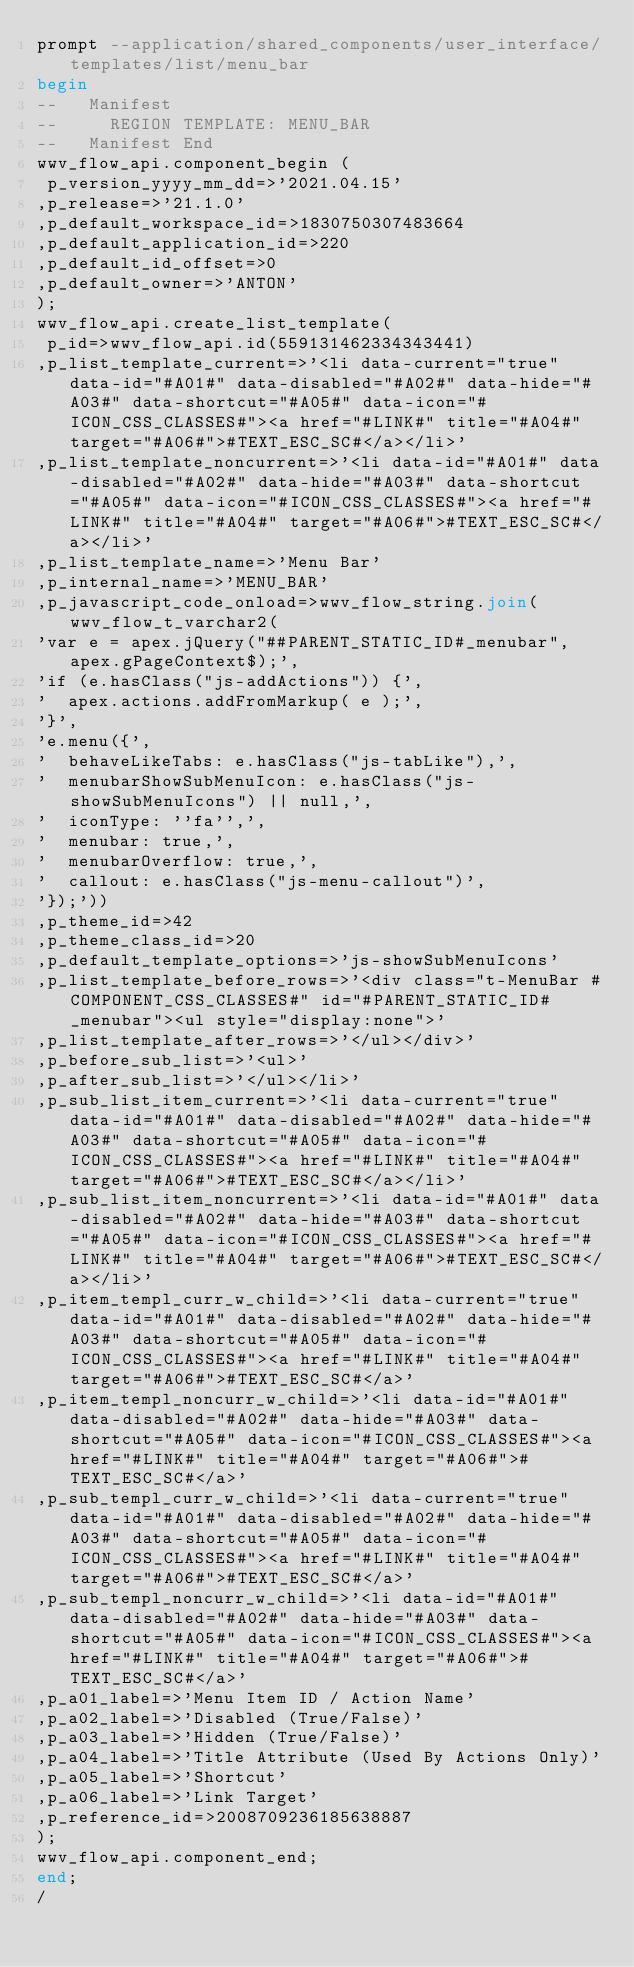<code> <loc_0><loc_0><loc_500><loc_500><_SQL_>prompt --application/shared_components/user_interface/templates/list/menu_bar
begin
--   Manifest
--     REGION TEMPLATE: MENU_BAR
--   Manifest End
wwv_flow_api.component_begin (
 p_version_yyyy_mm_dd=>'2021.04.15'
,p_release=>'21.1.0'
,p_default_workspace_id=>1830750307483664
,p_default_application_id=>220
,p_default_id_offset=>0
,p_default_owner=>'ANTON'
);
wwv_flow_api.create_list_template(
 p_id=>wwv_flow_api.id(559131462334343441)
,p_list_template_current=>'<li data-current="true" data-id="#A01#" data-disabled="#A02#" data-hide="#A03#" data-shortcut="#A05#" data-icon="#ICON_CSS_CLASSES#"><a href="#LINK#" title="#A04#" target="#A06#">#TEXT_ESC_SC#</a></li>'
,p_list_template_noncurrent=>'<li data-id="#A01#" data-disabled="#A02#" data-hide="#A03#" data-shortcut="#A05#" data-icon="#ICON_CSS_CLASSES#"><a href="#LINK#" title="#A04#" target="#A06#">#TEXT_ESC_SC#</a></li>'
,p_list_template_name=>'Menu Bar'
,p_internal_name=>'MENU_BAR'
,p_javascript_code_onload=>wwv_flow_string.join(wwv_flow_t_varchar2(
'var e = apex.jQuery("##PARENT_STATIC_ID#_menubar", apex.gPageContext$);',
'if (e.hasClass("js-addActions")) {',
'  apex.actions.addFromMarkup( e );',
'}',
'e.menu({',
'  behaveLikeTabs: e.hasClass("js-tabLike"),',
'  menubarShowSubMenuIcon: e.hasClass("js-showSubMenuIcons") || null,',
'  iconType: ''fa'',',
'  menubar: true,',
'  menubarOverflow: true,',
'  callout: e.hasClass("js-menu-callout")',
'});'))
,p_theme_id=>42
,p_theme_class_id=>20
,p_default_template_options=>'js-showSubMenuIcons'
,p_list_template_before_rows=>'<div class="t-MenuBar #COMPONENT_CSS_CLASSES#" id="#PARENT_STATIC_ID#_menubar"><ul style="display:none">'
,p_list_template_after_rows=>'</ul></div>'
,p_before_sub_list=>'<ul>'
,p_after_sub_list=>'</ul></li>'
,p_sub_list_item_current=>'<li data-current="true" data-id="#A01#" data-disabled="#A02#" data-hide="#A03#" data-shortcut="#A05#" data-icon="#ICON_CSS_CLASSES#"><a href="#LINK#" title="#A04#" target="#A06#">#TEXT_ESC_SC#</a></li>'
,p_sub_list_item_noncurrent=>'<li data-id="#A01#" data-disabled="#A02#" data-hide="#A03#" data-shortcut="#A05#" data-icon="#ICON_CSS_CLASSES#"><a href="#LINK#" title="#A04#" target="#A06#">#TEXT_ESC_SC#</a></li>'
,p_item_templ_curr_w_child=>'<li data-current="true" data-id="#A01#" data-disabled="#A02#" data-hide="#A03#" data-shortcut="#A05#" data-icon="#ICON_CSS_CLASSES#"><a href="#LINK#" title="#A04#" target="#A06#">#TEXT_ESC_SC#</a>'
,p_item_templ_noncurr_w_child=>'<li data-id="#A01#" data-disabled="#A02#" data-hide="#A03#" data-shortcut="#A05#" data-icon="#ICON_CSS_CLASSES#"><a href="#LINK#" title="#A04#" target="#A06#">#TEXT_ESC_SC#</a>'
,p_sub_templ_curr_w_child=>'<li data-current="true" data-id="#A01#" data-disabled="#A02#" data-hide="#A03#" data-shortcut="#A05#" data-icon="#ICON_CSS_CLASSES#"><a href="#LINK#" title="#A04#" target="#A06#">#TEXT_ESC_SC#</a>'
,p_sub_templ_noncurr_w_child=>'<li data-id="#A01#" data-disabled="#A02#" data-hide="#A03#" data-shortcut="#A05#" data-icon="#ICON_CSS_CLASSES#"><a href="#LINK#" title="#A04#" target="#A06#">#TEXT_ESC_SC#</a>'
,p_a01_label=>'Menu Item ID / Action Name'
,p_a02_label=>'Disabled (True/False)'
,p_a03_label=>'Hidden (True/False)'
,p_a04_label=>'Title Attribute (Used By Actions Only)'
,p_a05_label=>'Shortcut'
,p_a06_label=>'Link Target'
,p_reference_id=>2008709236185638887
);
wwv_flow_api.component_end;
end;
/
</code> 